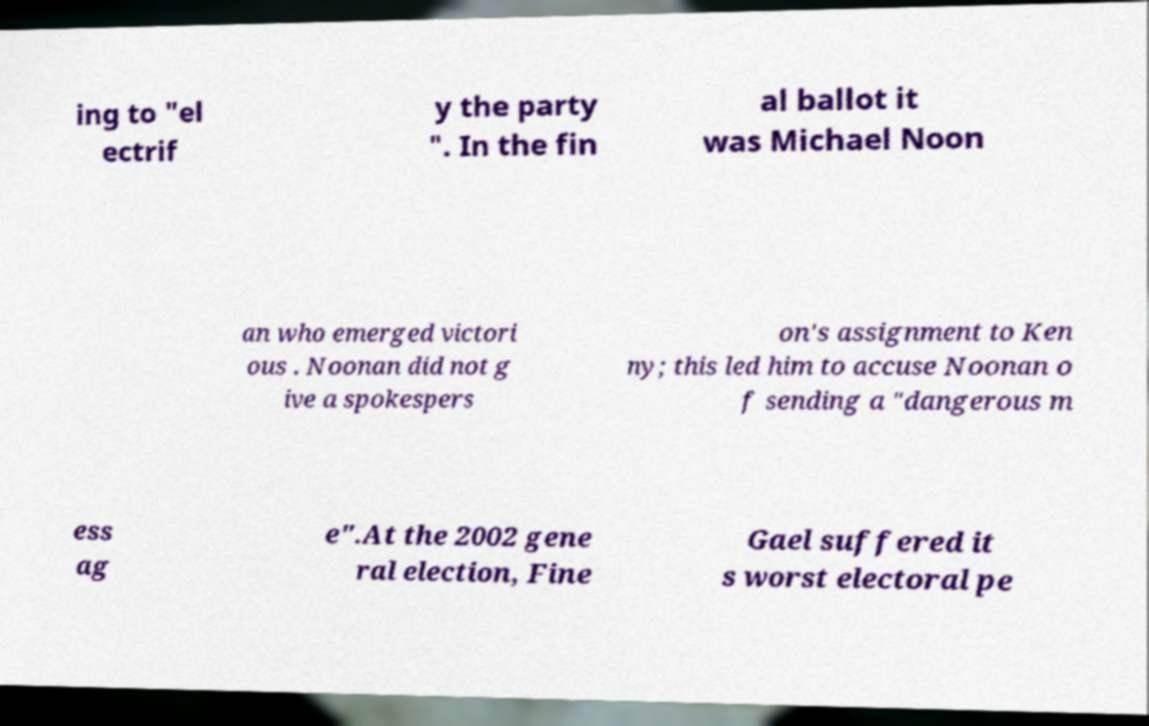Could you assist in decoding the text presented in this image and type it out clearly? ing to "el ectrif y the party ". In the fin al ballot it was Michael Noon an who emerged victori ous . Noonan did not g ive a spokespers on's assignment to Ken ny; this led him to accuse Noonan o f sending a "dangerous m ess ag e".At the 2002 gene ral election, Fine Gael suffered it s worst electoral pe 